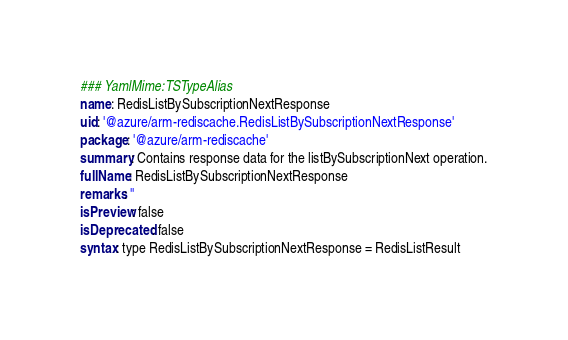<code> <loc_0><loc_0><loc_500><loc_500><_YAML_>### YamlMime:TSTypeAlias
name: RedisListBySubscriptionNextResponse
uid: '@azure/arm-rediscache.RedisListBySubscriptionNextResponse'
package: '@azure/arm-rediscache'
summary: Contains response data for the listBySubscriptionNext operation.
fullName: RedisListBySubscriptionNextResponse
remarks: ''
isPreview: false
isDeprecated: false
syntax: type RedisListBySubscriptionNextResponse = RedisListResult
</code> 